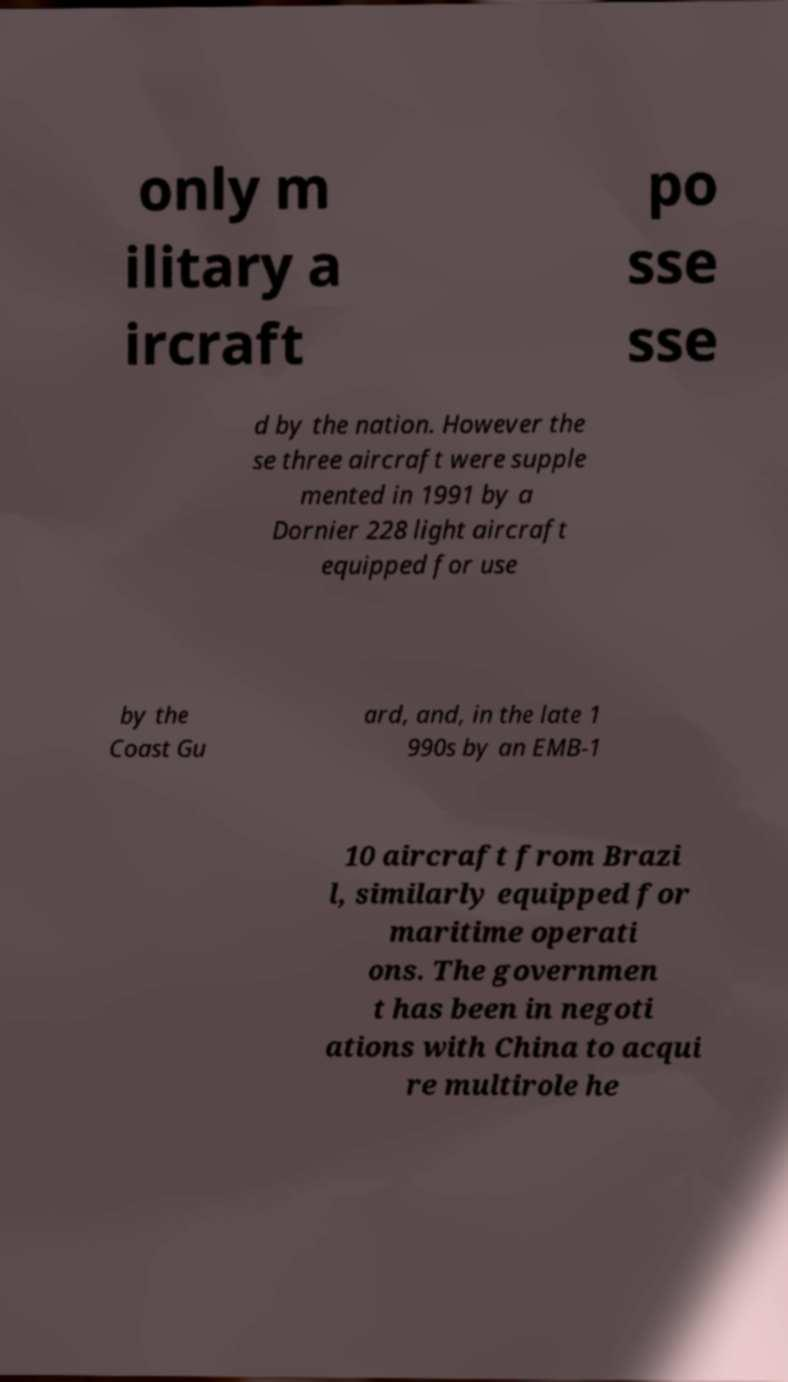I need the written content from this picture converted into text. Can you do that? only m ilitary a ircraft po sse sse d by the nation. However the se three aircraft were supple mented in 1991 by a Dornier 228 light aircraft equipped for use by the Coast Gu ard, and, in the late 1 990s by an EMB-1 10 aircraft from Brazi l, similarly equipped for maritime operati ons. The governmen t has been in negoti ations with China to acqui re multirole he 